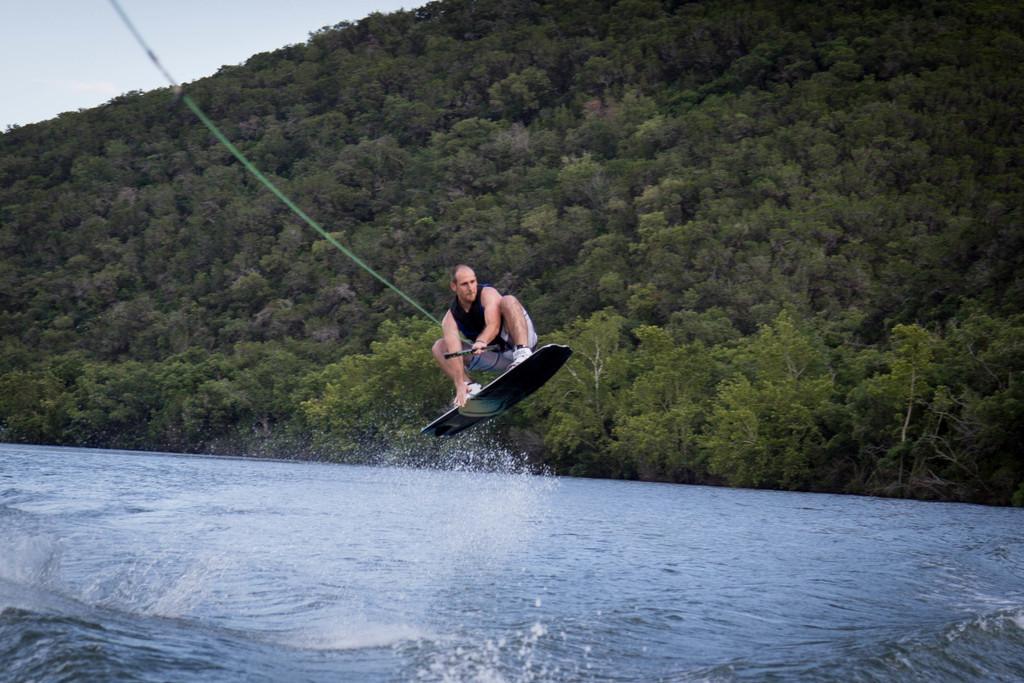In one or two sentences, can you explain what this image depicts? In this image we can see a person on the surfing board holding a rope. In the background of the image there are trees. At the bottom of the image there is water. 